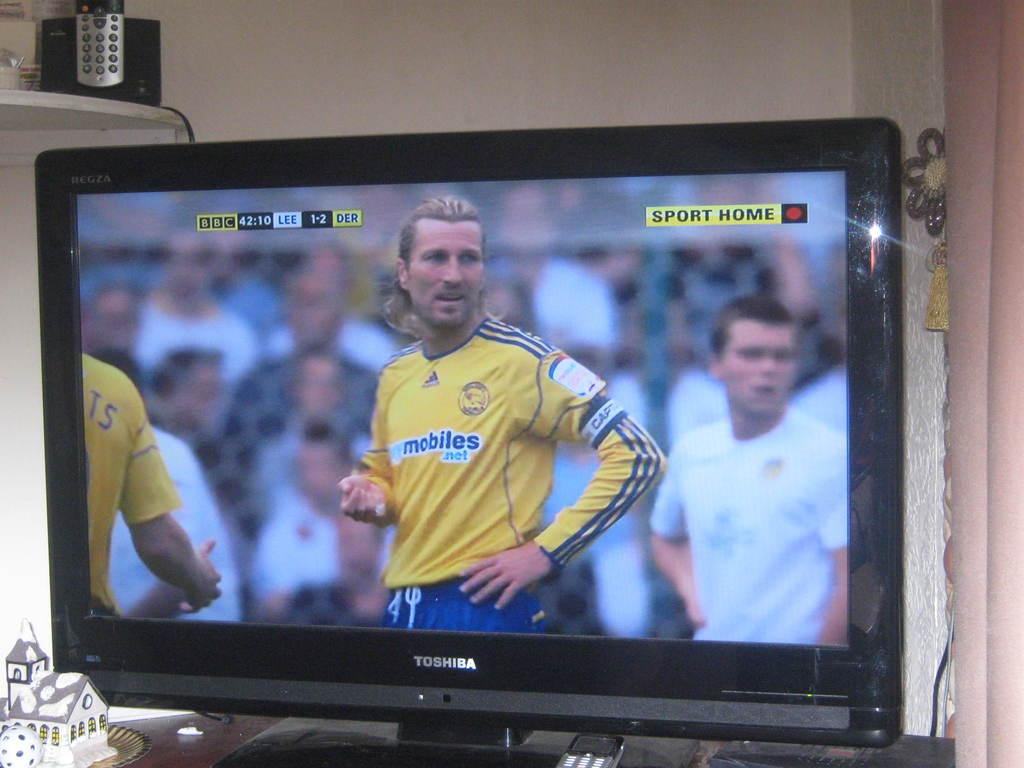<image>
Describe the image concisely. The BBC television is the one showing the soccer game. 